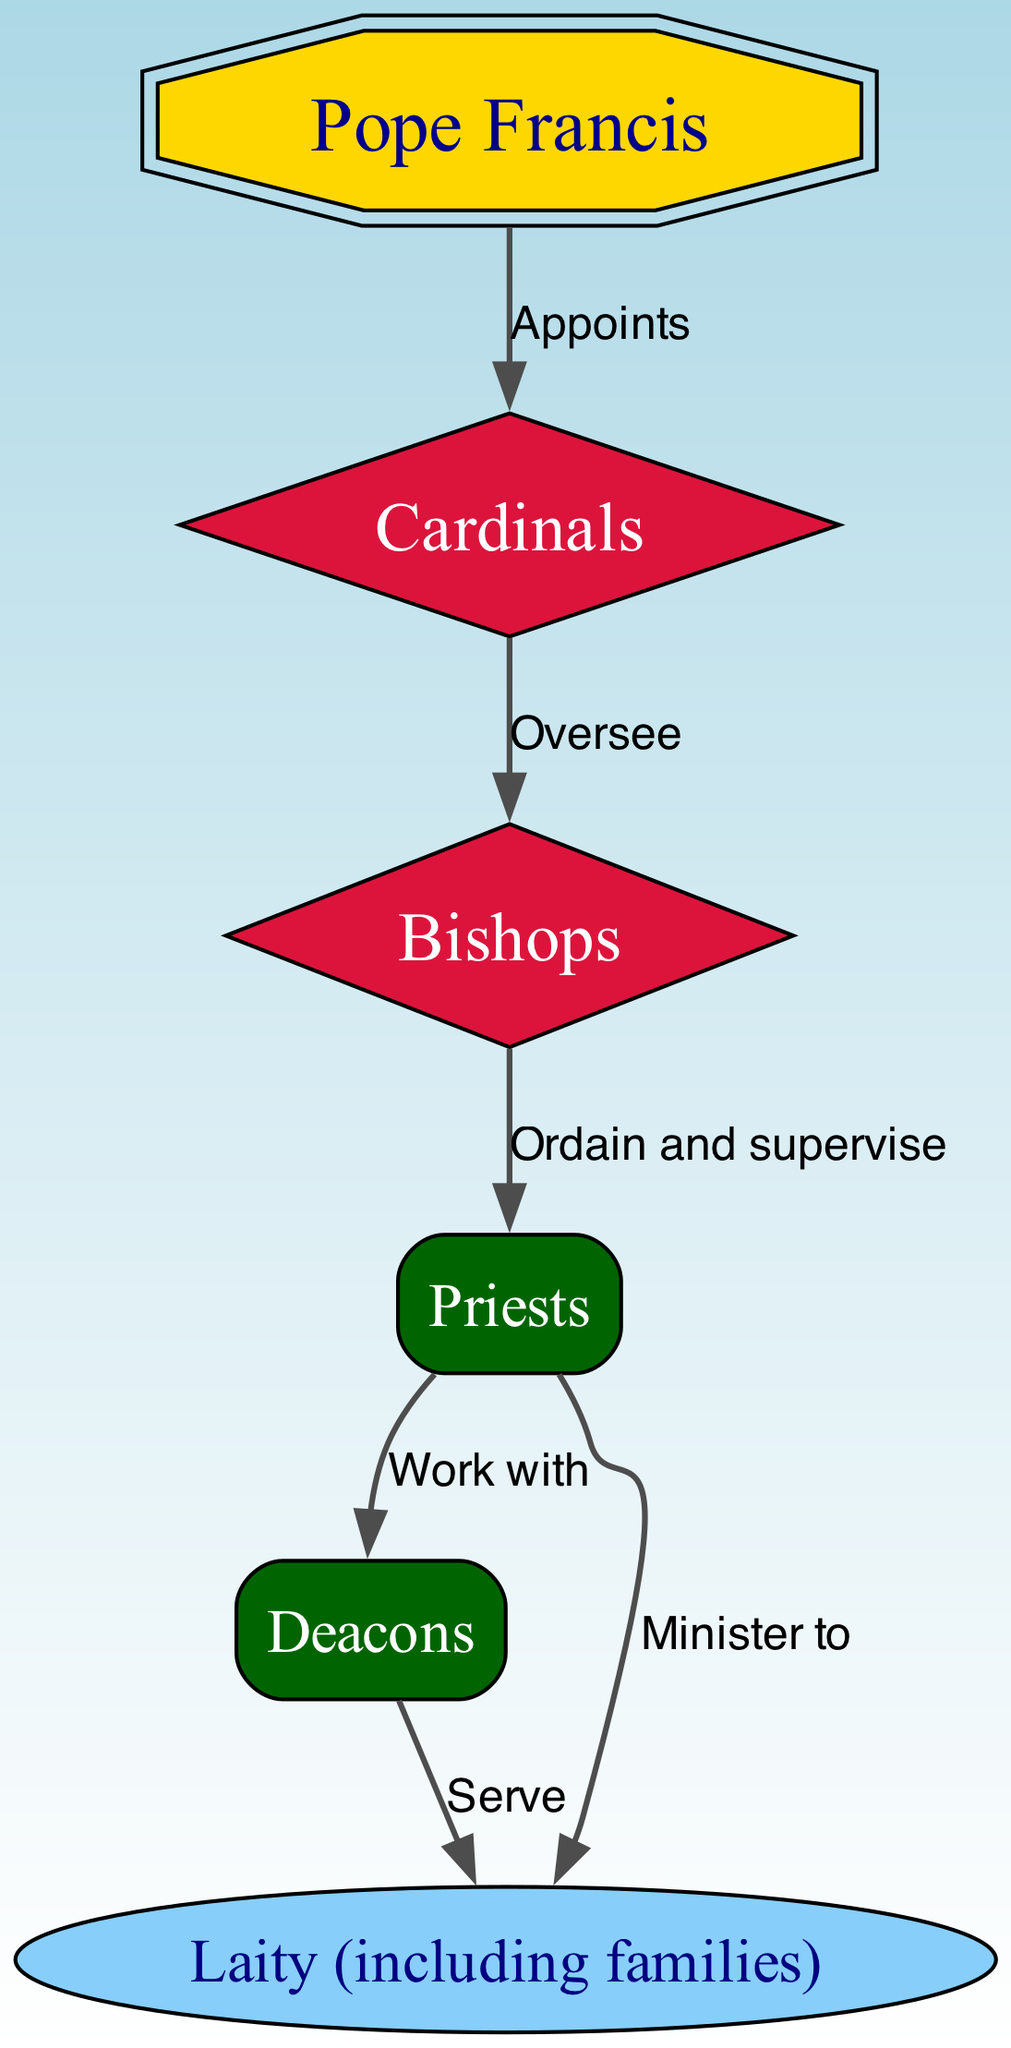What is the highest position in the Roman Catholic Church? The diagram clearly indicates that the Pope is at the top of the hierarchy, represented as the single node labeled "Pope Francis."
Answer: Pope Francis How many nodes are in the diagram? Counting the nodes listed in the diagram: Pope, Cardinals, Bishops, Priests, Deacons, and Laity, we find a total of six distinct nodes.
Answer: 6 Who appoints the Cardinals? The diagram shows a directed edge from the Pope to the Cardinals, labeled "Appoints," indicating that the Pope is responsible for this action.
Answer: Pope Francis Which group do Bishops oversee? According to the edges in the diagram, there is a directed edge from Cardinals to Bishops, which indicates that Cardinals oversee Bishops.
Answer: Bishops How do Priests interact with Deacons? The diagram illustrates a connection between Priests and Deacons, with the edge labeled "Work with," indicating a collaborative relationship between the two groups.
Answer: Work with What is the role of Deacons in relation to the Laity? The diagram contains an edge from Deacons to Laity labeled "Serve," indicating that Deacons serve the laity within the church structure.
Answer: Serve Who do Priests minister to? The diagram features an edge leading from Priests to Laity, which is labeled "Minister to," clarifying that Priests provide ministry to the Laity.
Answer: Laity What is the color used for the node representing the Pope? The diagram specifies a distinctive gold color for the Pope's node, distinguishing it from other nodes in the hierarchy.
Answer: Gold What shape represents the Cardinals in the diagram? The diagram utilizes a diamond shape for the Cardinals, as indicated in the node specifications.
Answer: Diamond 